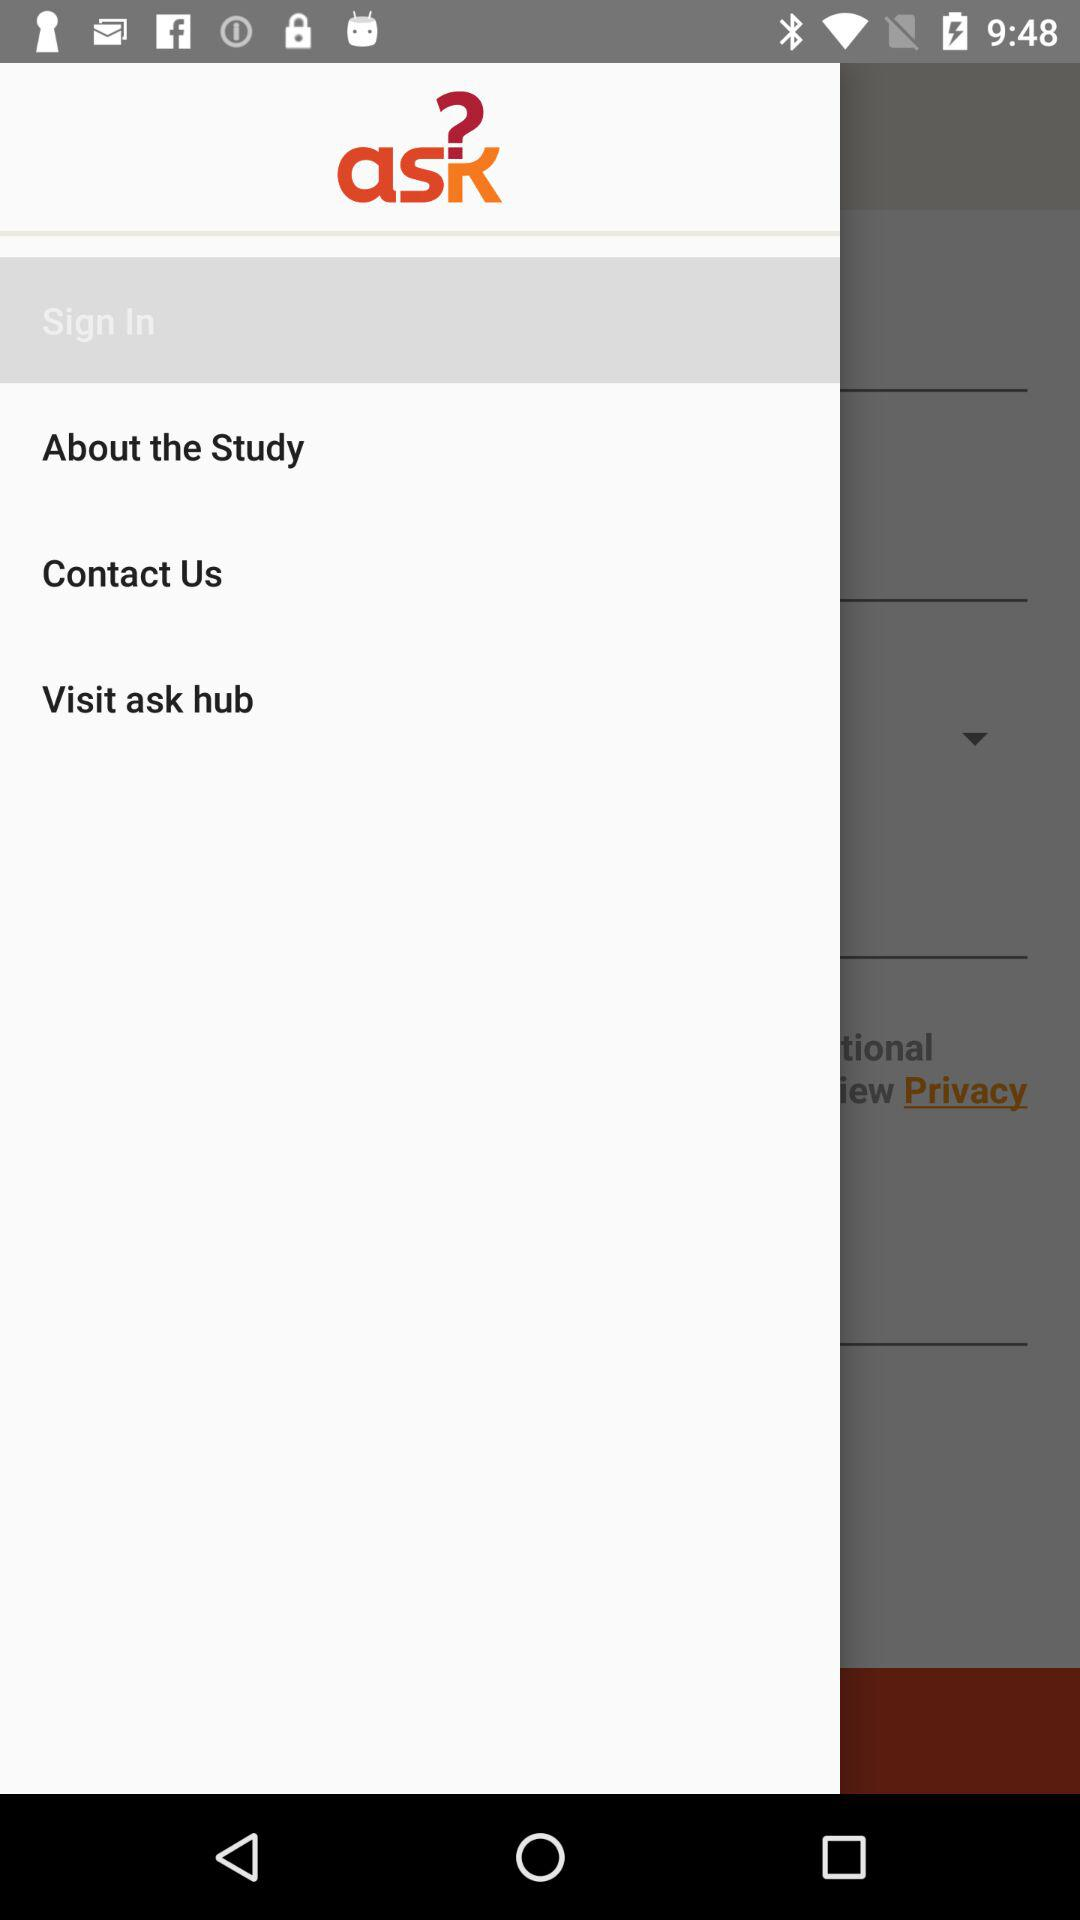What is the selected item? The selected item is "Sign In". 